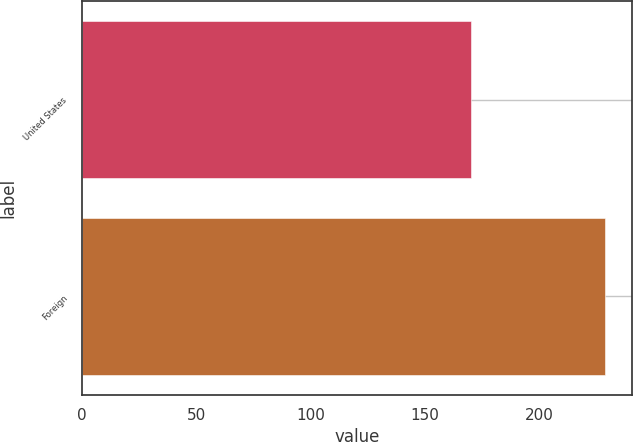Convert chart to OTSL. <chart><loc_0><loc_0><loc_500><loc_500><bar_chart><fcel>United States<fcel>Foreign<nl><fcel>170<fcel>229<nl></chart> 